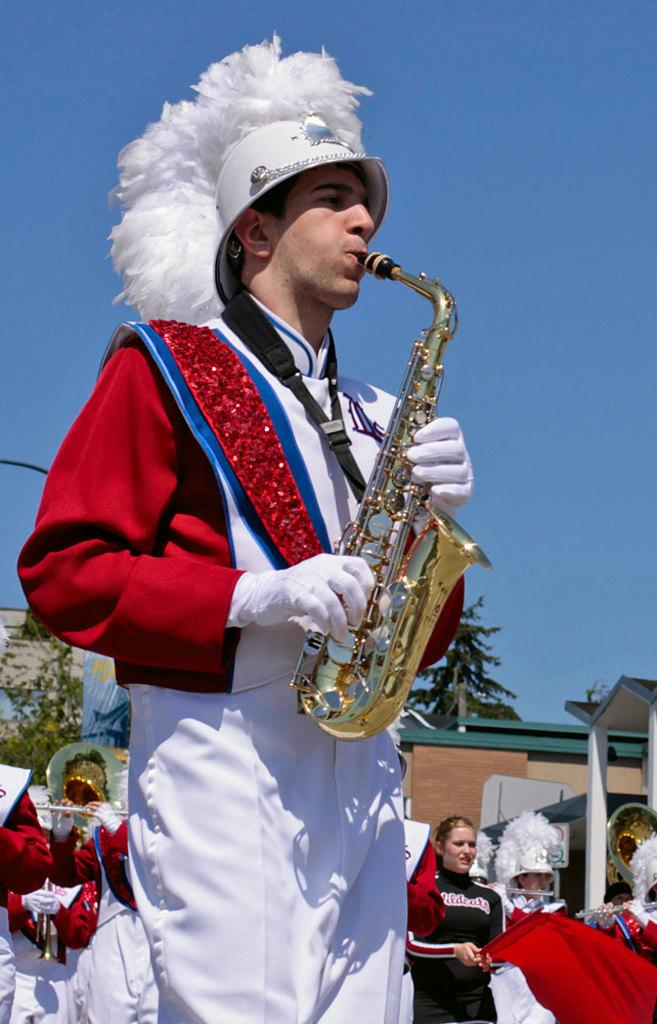What are the people in the image doing? The people in the image are standing and playing musical instruments. Can you describe the setting of the image? There are buildings and trees in the background of the image. How many groups of people can be seen in the image? The number of groups of people cannot be determined from the provided facts. What type of chair is being used by the people playing musical instruments in the image? There is no chair present in the image; the people are standing while playing their instruments. 